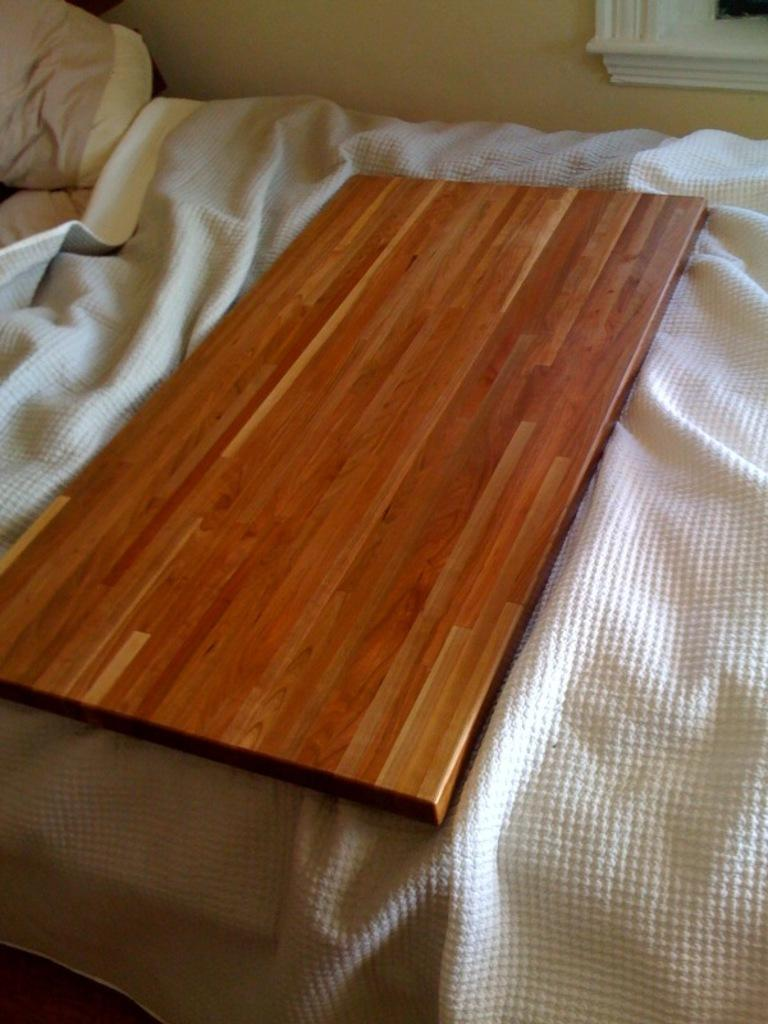What is the main object in the image? There is a wooden plank in the image. Where is the wooden plank placed? The wooden plank is placed on a bed. What color is the bed sheet on the bed? There is a white bed sheet on the bed. What can be seen in the background of the image? There is a wall visible in the background of the image. How many beads are on the mother's necklace in the image? There is no mother or necklace present in the image; it features a wooden plank on a bed with a white bed sheet and a wall in the background. 